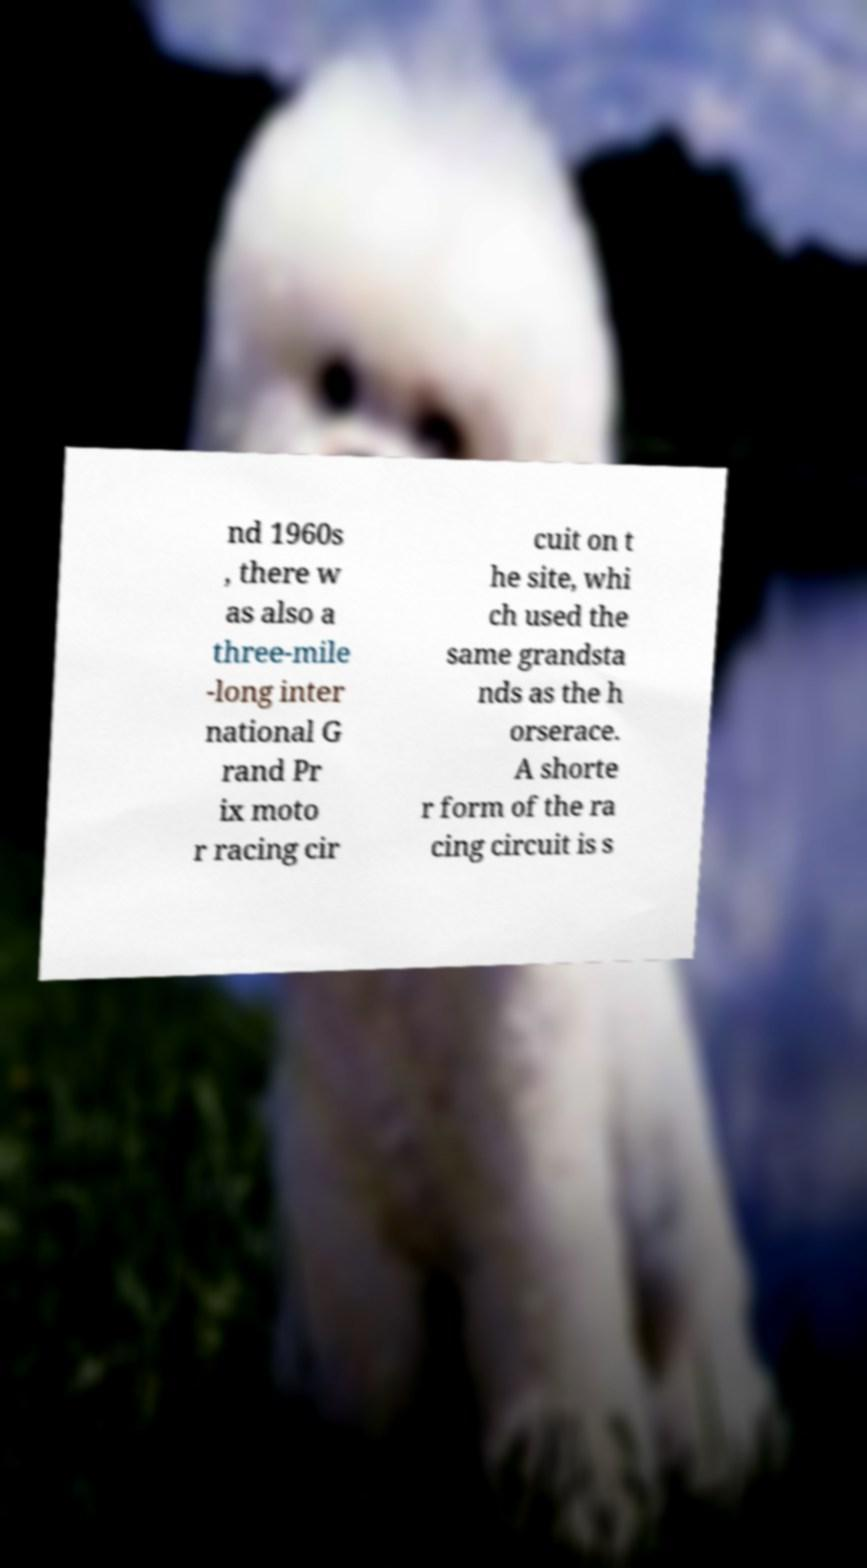I need the written content from this picture converted into text. Can you do that? nd 1960s , there w as also a three-mile -long inter national G rand Pr ix moto r racing cir cuit on t he site, whi ch used the same grandsta nds as the h orserace. A shorte r form of the ra cing circuit is s 